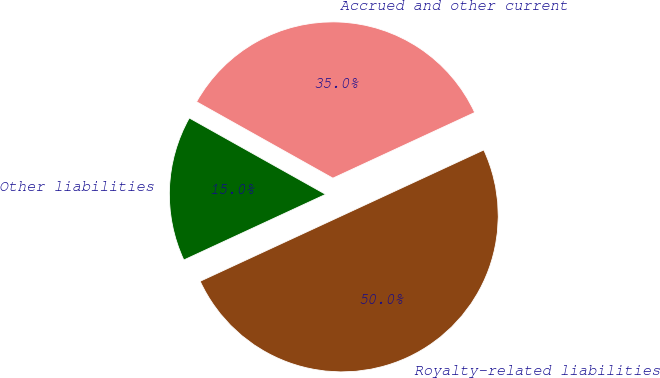<chart> <loc_0><loc_0><loc_500><loc_500><pie_chart><fcel>Accrued and other current<fcel>Other liabilities<fcel>Royalty-related liabilities<nl><fcel>34.97%<fcel>15.03%<fcel>50.0%<nl></chart> 